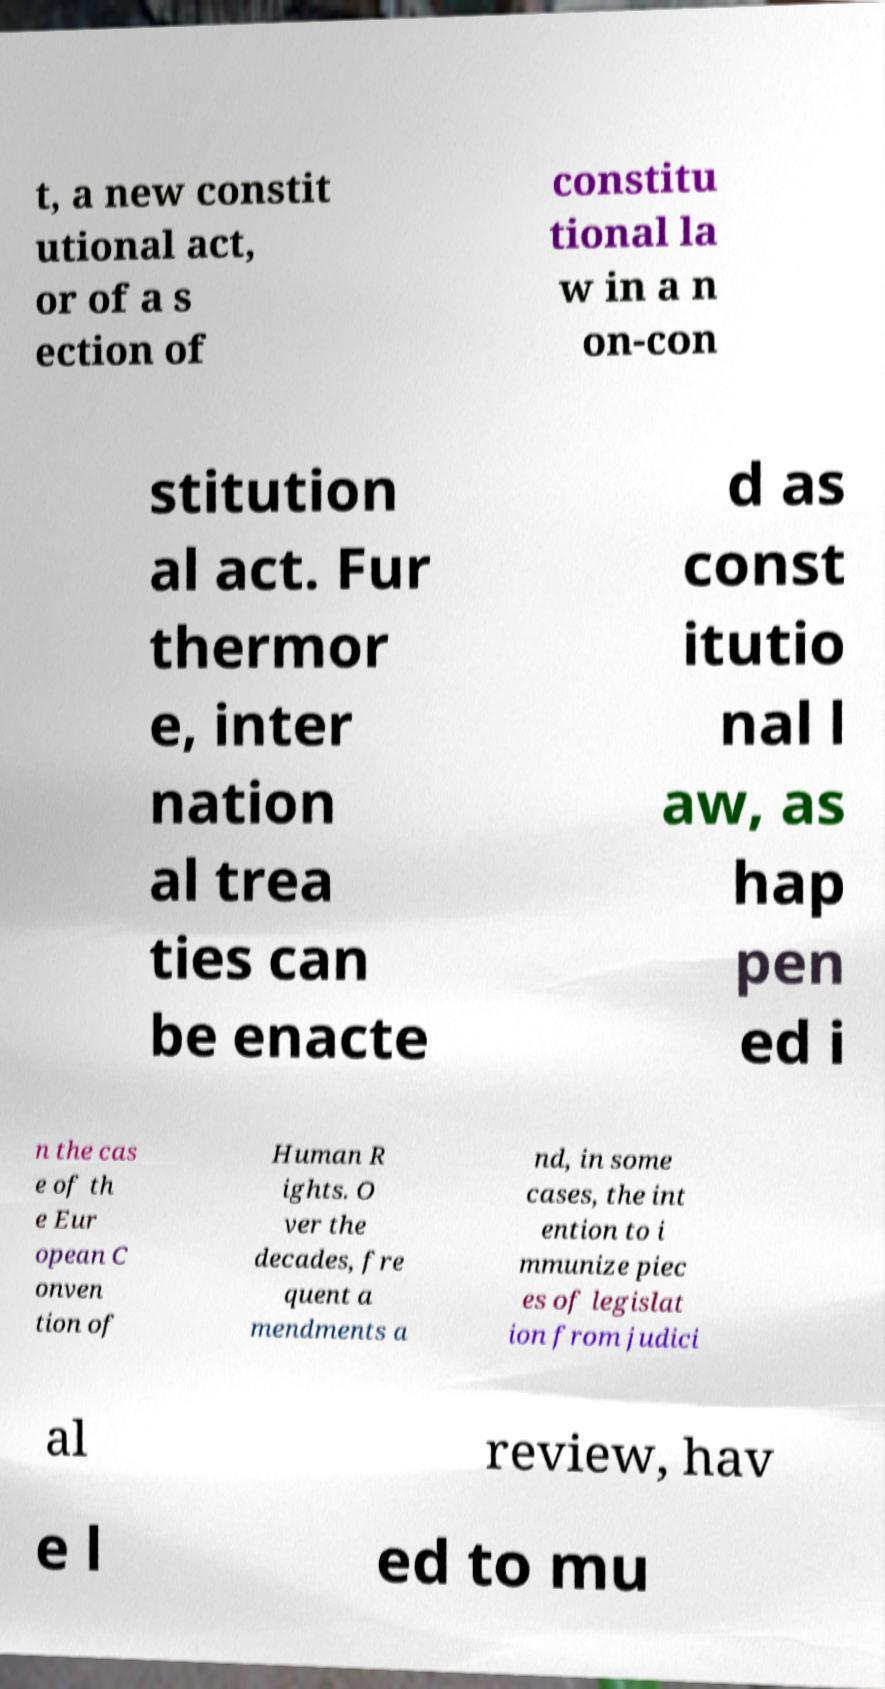Could you extract and type out the text from this image? t, a new constit utional act, or of a s ection of constitu tional la w in a n on-con stitution al act. Fur thermor e, inter nation al trea ties can be enacte d as const itutio nal l aw, as hap pen ed i n the cas e of th e Eur opean C onven tion of Human R ights. O ver the decades, fre quent a mendments a nd, in some cases, the int ention to i mmunize piec es of legislat ion from judici al review, hav e l ed to mu 